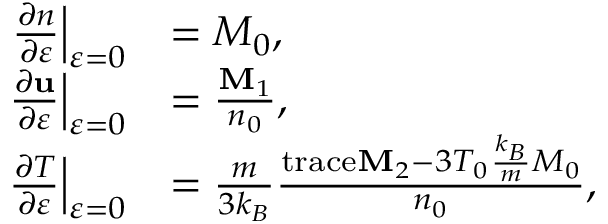Convert formula to latex. <formula><loc_0><loc_0><loc_500><loc_500>\begin{array} { r l } { \frac { \partial n } { \partial \varepsilon } \right | _ { \varepsilon = 0 } } & { = M _ { 0 } , } \\ { \frac { \partial u } { \partial \varepsilon } \right | _ { \varepsilon = 0 } } & { = \frac { M _ { 1 } } { n _ { 0 } } , } \\ { \frac { \partial T } { \partial \varepsilon } \right | _ { \varepsilon = 0 } } & { = \frac { m } { 3 k _ { B } } \frac { t r a c e M _ { 2 } - 3 T _ { 0 } \frac { k _ { B } } { m } M _ { 0 } } { n _ { 0 } } , } \end{array}</formula> 